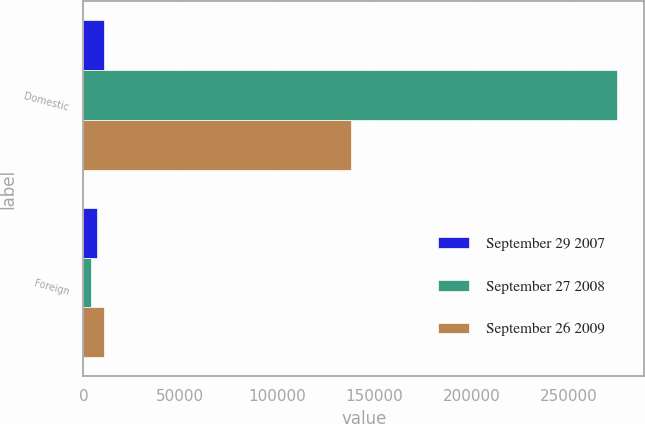Convert chart to OTSL. <chart><loc_0><loc_0><loc_500><loc_500><stacked_bar_chart><ecel><fcel>Domestic<fcel>Foreign<nl><fcel>September 29 2007<fcel>10830<fcel>7134<nl><fcel>September 27 2008<fcel>275091<fcel>4050<nl><fcel>September 26 2009<fcel>137659<fcel>10830<nl></chart> 